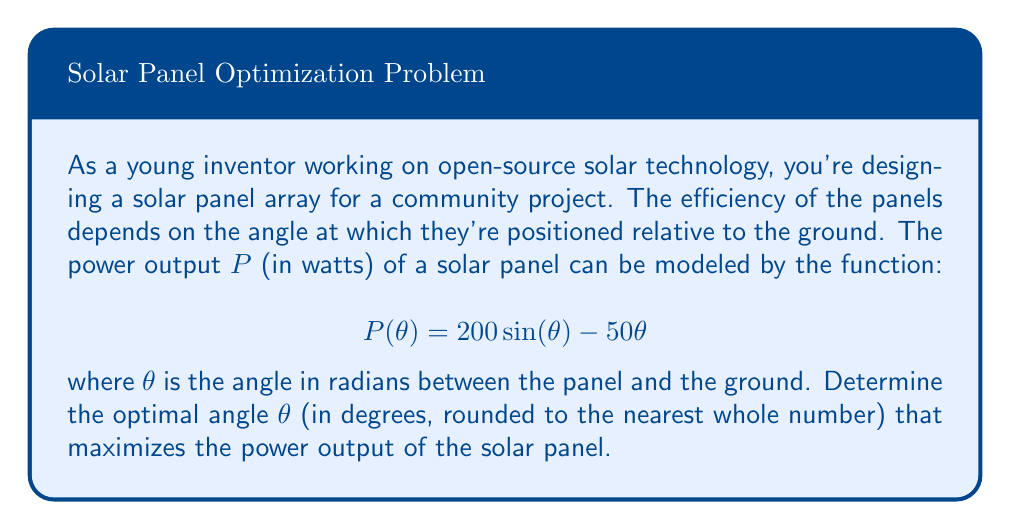Show me your answer to this math problem. To find the optimal angle that maximizes the power output, we need to follow these steps:

1) First, we need to find the critical points of the function $P(\theta)$ by taking its derivative and setting it equal to zero.

2) The derivative of $P(\theta)$ is:
   $$P'(\theta) = 200 \cos(\theta) - 50$$

3) Set $P'(\theta) = 0$ and solve for $\theta$:
   $$200 \cos(\theta) - 50 = 0$$
   $$200 \cos(\theta) = 50$$
   $$\cos(\theta) = \frac{1}{4}$$

4) Taking the inverse cosine (arccos) of both sides:
   $$\theta = \arccos(\frac{1}{4})$$

5) This gives us the critical point in radians. To convert to degrees, multiply by $\frac{180}{\pi}$:
   $$\theta = \arccos(\frac{1}{4}) \cdot \frac{180}{\pi} \approx 75.5225^\circ$$

6) Rounding to the nearest whole number:
   $$\theta \approx 76^\circ$$

7) To confirm this is a maximum, we can check the second derivative:
   $$P''(\theta) = -200 \sin(\theta)$$
   At $\theta = \arccos(\frac{1}{4})$, $P''(\theta)$ is negative, confirming a maximum.

Therefore, the optimal angle for maximum efficiency is approximately 76 degrees.
Answer: 76 degrees 